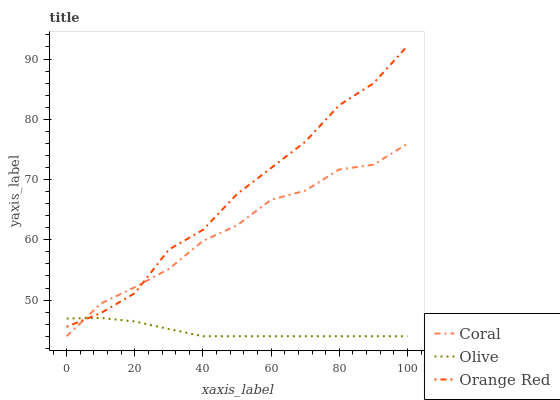Does Olive have the minimum area under the curve?
Answer yes or no. Yes. Does Orange Red have the maximum area under the curve?
Answer yes or no. Yes. Does Coral have the minimum area under the curve?
Answer yes or no. No. Does Coral have the maximum area under the curve?
Answer yes or no. No. Is Olive the smoothest?
Answer yes or no. Yes. Is Orange Red the roughest?
Answer yes or no. Yes. Is Coral the smoothest?
Answer yes or no. No. Is Coral the roughest?
Answer yes or no. No. Does Orange Red have the lowest value?
Answer yes or no. No. Does Coral have the highest value?
Answer yes or no. No. 